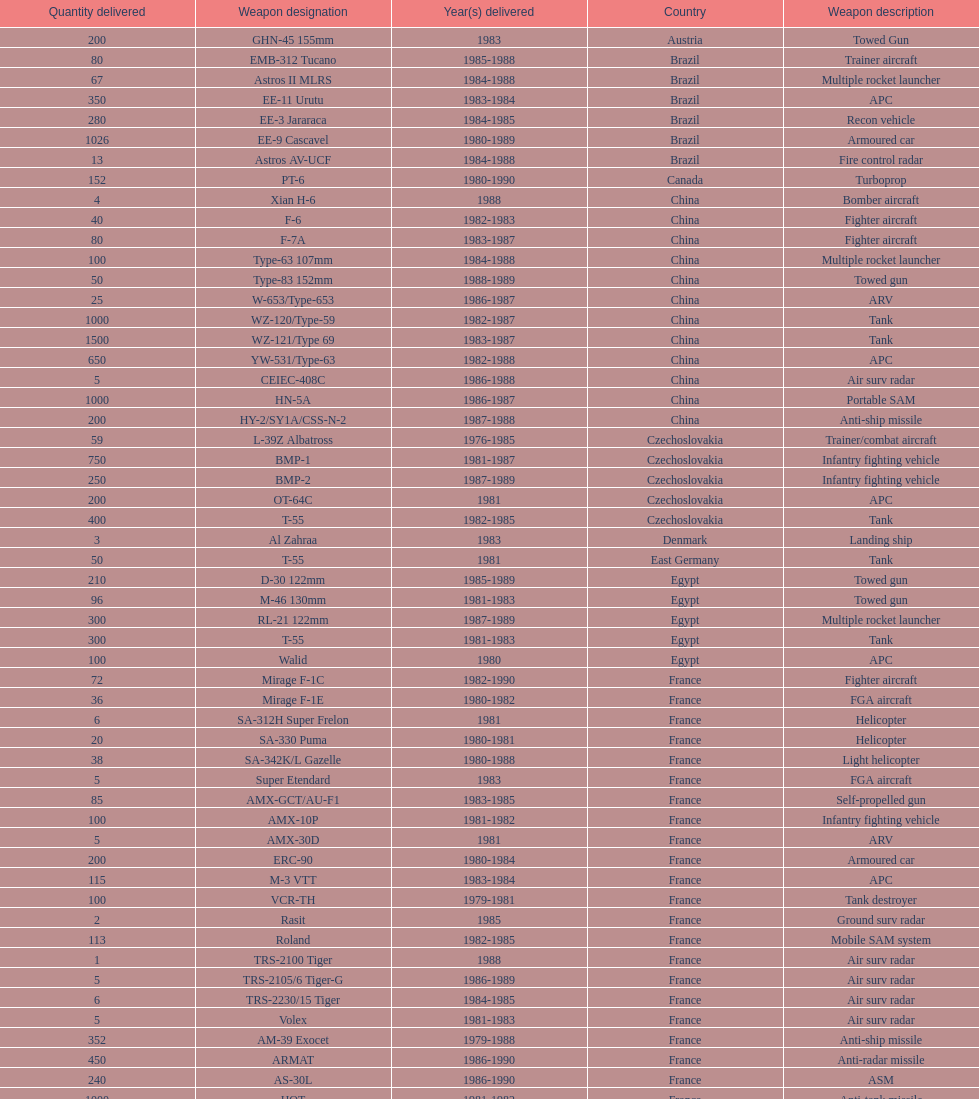Which country had the largest number of towed guns delivered? Soviet Union. 